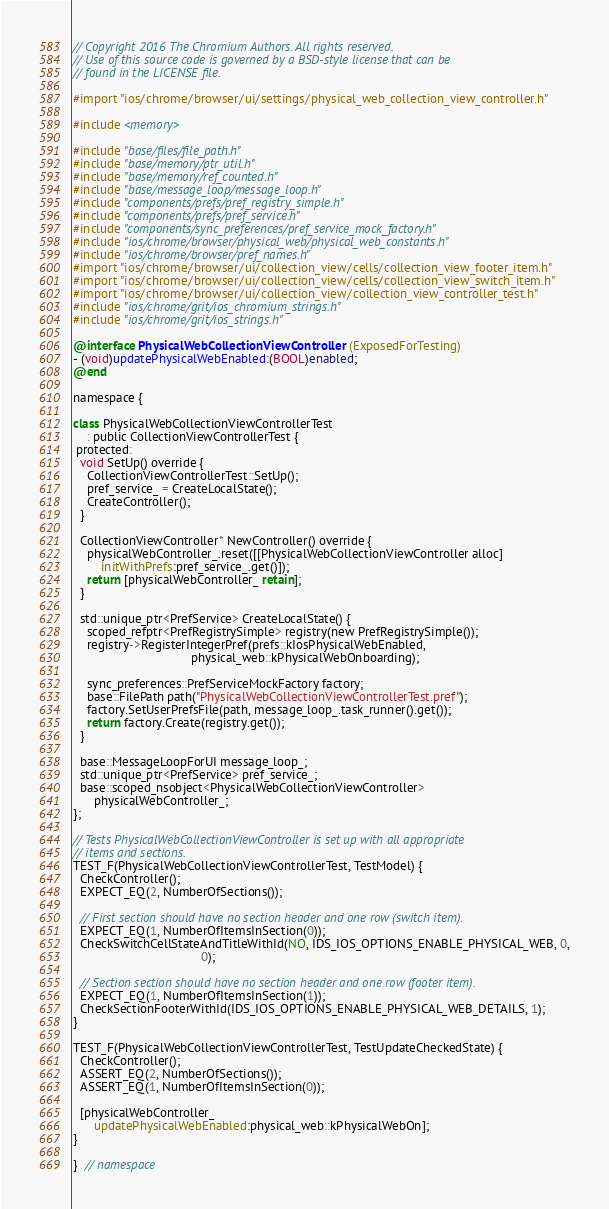<code> <loc_0><loc_0><loc_500><loc_500><_ObjectiveC_>// Copyright 2016 The Chromium Authors. All rights reserved.
// Use of this source code is governed by a BSD-style license that can be
// found in the LICENSE file.

#import "ios/chrome/browser/ui/settings/physical_web_collection_view_controller.h"

#include <memory>

#include "base/files/file_path.h"
#include "base/memory/ptr_util.h"
#include "base/memory/ref_counted.h"
#include "base/message_loop/message_loop.h"
#include "components/prefs/pref_registry_simple.h"
#include "components/prefs/pref_service.h"
#include "components/sync_preferences/pref_service_mock_factory.h"
#include "ios/chrome/browser/physical_web/physical_web_constants.h"
#include "ios/chrome/browser/pref_names.h"
#import "ios/chrome/browser/ui/collection_view/cells/collection_view_footer_item.h"
#import "ios/chrome/browser/ui/collection_view/cells/collection_view_switch_item.h"
#import "ios/chrome/browser/ui/collection_view/collection_view_controller_test.h"
#include "ios/chrome/grit/ios_chromium_strings.h"
#include "ios/chrome/grit/ios_strings.h"

@interface PhysicalWebCollectionViewController (ExposedForTesting)
- (void)updatePhysicalWebEnabled:(BOOL)enabled;
@end

namespace {

class PhysicalWebCollectionViewControllerTest
    : public CollectionViewControllerTest {
 protected:
  void SetUp() override {
    CollectionViewControllerTest::SetUp();
    pref_service_ = CreateLocalState();
    CreateController();
  }

  CollectionViewController* NewController() override {
    physicalWebController_.reset([[PhysicalWebCollectionViewController alloc]
        initWithPrefs:pref_service_.get()]);
    return [physicalWebController_ retain];
  }

  std::unique_ptr<PrefService> CreateLocalState() {
    scoped_refptr<PrefRegistrySimple> registry(new PrefRegistrySimple());
    registry->RegisterIntegerPref(prefs::kIosPhysicalWebEnabled,
                                  physical_web::kPhysicalWebOnboarding);

    sync_preferences::PrefServiceMockFactory factory;
    base::FilePath path("PhysicalWebCollectionViewControllerTest.pref");
    factory.SetUserPrefsFile(path, message_loop_.task_runner().get());
    return factory.Create(registry.get());
  }

  base::MessageLoopForUI message_loop_;
  std::unique_ptr<PrefService> pref_service_;
  base::scoped_nsobject<PhysicalWebCollectionViewController>
      physicalWebController_;
};

// Tests PhysicalWebCollectionViewController is set up with all appropriate
// items and sections.
TEST_F(PhysicalWebCollectionViewControllerTest, TestModel) {
  CheckController();
  EXPECT_EQ(2, NumberOfSections());

  // First section should have no section header and one row (switch item).
  EXPECT_EQ(1, NumberOfItemsInSection(0));
  CheckSwitchCellStateAndTitleWithId(NO, IDS_IOS_OPTIONS_ENABLE_PHYSICAL_WEB, 0,
                                     0);

  // Section section should have no section header and one row (footer item).
  EXPECT_EQ(1, NumberOfItemsInSection(1));
  CheckSectionFooterWithId(IDS_IOS_OPTIONS_ENABLE_PHYSICAL_WEB_DETAILS, 1);
}

TEST_F(PhysicalWebCollectionViewControllerTest, TestUpdateCheckedState) {
  CheckController();
  ASSERT_EQ(2, NumberOfSections());
  ASSERT_EQ(1, NumberOfItemsInSection(0));

  [physicalWebController_
      updatePhysicalWebEnabled:physical_web::kPhysicalWebOn];
}

}  // namespace
</code> 